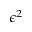<formula> <loc_0><loc_0><loc_500><loc_500>\epsilon ^ { 2 }</formula> 